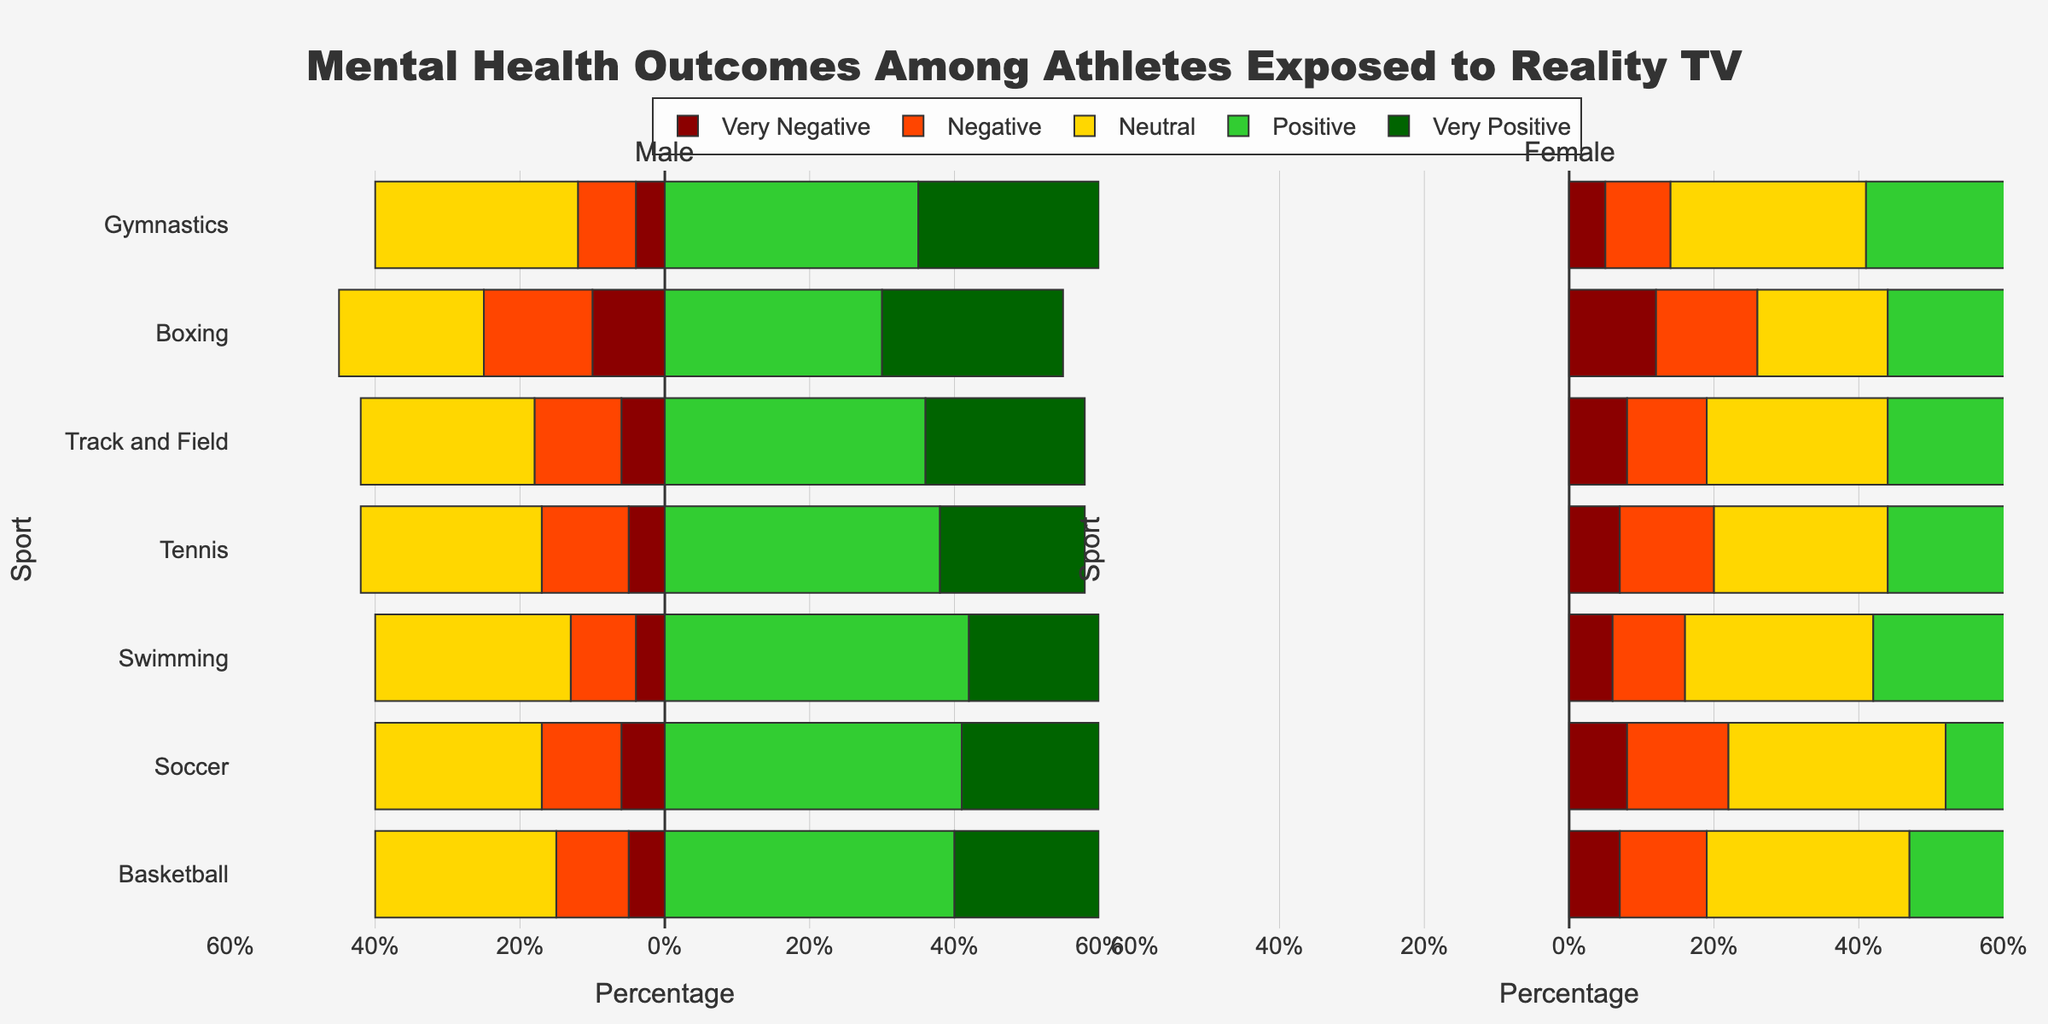What sport and gender combinations exhibit the highest percentage of highly negative mental health outcomes? Looking at the bars colored in very dark red for both Male and Female sections on the Y-axis for each sport, the highest percentage is found in Male Boxing with 10% and Female Boxing with 12%.
Answer: Male Boxing (10%), Female Boxing (12%) Which sport shows the most positive mental health outcomes for males? Check the green bar lengths for males. Swimming has the highest percentage of positive and very positive responses, totaling 60% (42% + 18%).
Answer: Swimming (60%) Compare the range of neutral outcomes between male and female athletes in Basketball. Look at the yellow bars for neutral outcomes in Basketball for both genders. Males have 25%, and females have 28%.
Answer: Males (25%), Females (28%) If we compare the total percentage of negative outcomes (very negative and negative combined) for Male and Female Track and Field athletes, which gender fares better? Add very negative and negative percentages for both genders in Track and Field. For males, 6% + 12% = 18%. For females, 8% + 11% = 19%. Males fare slightly better.
Answer: Males (18%) Among female athletes, which sport has the highest combined percentage of positive and very positive mental health outcomes? Add the light green and dark green bars for every female sport. Gymnastics has the highest with 36% + 23% = 59%.
Answer: Gymnastics (59%) For male athletes, which sport has the lowest percentage of 'Neutral' responses? Check the yellow bars representing 'Neutral' responses for every male sport. Boxing has the lowest with 20%.
Answer: Boxing (20%) Which sport and gender combination has the highest percentage of very positive mental health outcomes? Find the darkest green bar on both the male and female side. Male Boxing has 25%, Female Track and Field has 23%. The highest percentage is seen in Male Gymnastics with 25%.
Answer: Male Gymnastics (25%) Calculate the average percentage of positive outcomes for female Soccer and female Tennis athletes. Add the positive and very positive values for female Soccer and Tennis, then divide by 2. Soccer: 32% + 16% = 48%, Tennis: 35% + 21% = 56%, Average = (48 + 56)/2 = 52%.
Answer: 52% Is there any sport where both male and female athletes have exactly the same percentage in any mental health outcome category? Go through every sport and category, comparing male and female percentages. Both male and female Gymnastics athletes have 27% in the 'Neutral' category.
Answer: Gymnastics (Neutral, 27%) Which sport has the most gender disparity in very negative mental health outcomes? Calculate the difference for very negative outcomes between genders for each sport. Boxing shows the most disparity with Male at 10% and Female at 12%, a disparity of 2%.
Answer: Boxing (2%) 